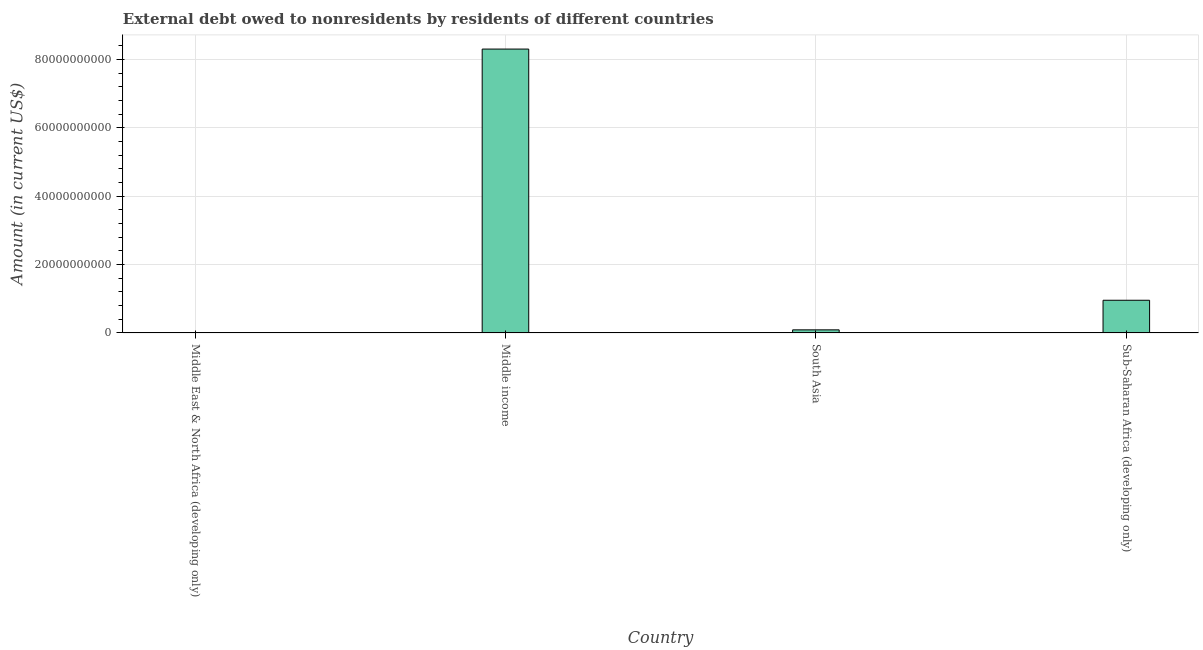Does the graph contain grids?
Ensure brevity in your answer.  Yes. What is the title of the graph?
Ensure brevity in your answer.  External debt owed to nonresidents by residents of different countries. What is the label or title of the X-axis?
Provide a short and direct response. Country. What is the label or title of the Y-axis?
Provide a succinct answer. Amount (in current US$). What is the debt in South Asia?
Ensure brevity in your answer.  9.05e+08. Across all countries, what is the maximum debt?
Provide a succinct answer. 8.31e+1. Across all countries, what is the minimum debt?
Keep it short and to the point. 0. What is the sum of the debt?
Your response must be concise. 9.36e+1. What is the difference between the debt in Middle income and Sub-Saharan Africa (developing only)?
Your response must be concise. 7.35e+1. What is the average debt per country?
Provide a succinct answer. 2.34e+1. What is the median debt?
Your response must be concise. 5.23e+09. In how many countries, is the debt greater than 68000000000 US$?
Give a very brief answer. 1. What is the ratio of the debt in South Asia to that in Sub-Saharan Africa (developing only)?
Give a very brief answer. 0.1. What is the difference between the highest and the second highest debt?
Keep it short and to the point. 7.35e+1. What is the difference between the highest and the lowest debt?
Offer a terse response. 8.31e+1. In how many countries, is the debt greater than the average debt taken over all countries?
Offer a terse response. 1. Are all the bars in the graph horizontal?
Give a very brief answer. No. How many countries are there in the graph?
Give a very brief answer. 4. What is the difference between two consecutive major ticks on the Y-axis?
Keep it short and to the point. 2.00e+1. Are the values on the major ticks of Y-axis written in scientific E-notation?
Your answer should be very brief. No. What is the Amount (in current US$) in Middle East & North Africa (developing only)?
Make the answer very short. 0. What is the Amount (in current US$) in Middle income?
Make the answer very short. 8.31e+1. What is the Amount (in current US$) of South Asia?
Offer a terse response. 9.05e+08. What is the Amount (in current US$) of Sub-Saharan Africa (developing only)?
Keep it short and to the point. 9.56e+09. What is the difference between the Amount (in current US$) in Middle income and South Asia?
Provide a short and direct response. 8.22e+1. What is the difference between the Amount (in current US$) in Middle income and Sub-Saharan Africa (developing only)?
Offer a very short reply. 7.35e+1. What is the difference between the Amount (in current US$) in South Asia and Sub-Saharan Africa (developing only)?
Your answer should be very brief. -8.66e+09. What is the ratio of the Amount (in current US$) in Middle income to that in South Asia?
Your answer should be compact. 91.8. What is the ratio of the Amount (in current US$) in Middle income to that in Sub-Saharan Africa (developing only)?
Your response must be concise. 8.69. What is the ratio of the Amount (in current US$) in South Asia to that in Sub-Saharan Africa (developing only)?
Give a very brief answer. 0.1. 